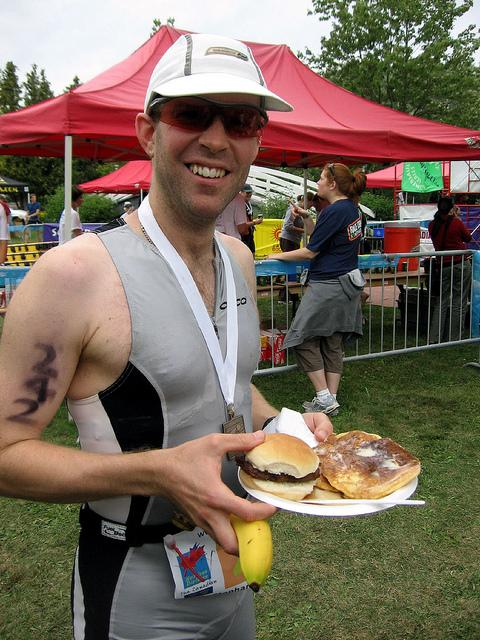Why does the man have numbers written on his arm?

Choices:
A) tattoo
B) event participant
C) as joke
D) for surgery event participant 